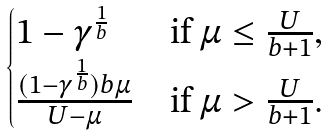<formula> <loc_0><loc_0><loc_500><loc_500>\begin{cases} 1 - \gamma ^ { \frac { 1 } { b } } & \text {if} \ \mu \leq \frac { U } { b + 1 } , \\ \frac { ( 1 - \gamma ^ { \frac { 1 } { b } } ) b \mu } { U - \mu } & \text {if} \ \mu > \frac { U } { b + 1 } . \end{cases}</formula> 